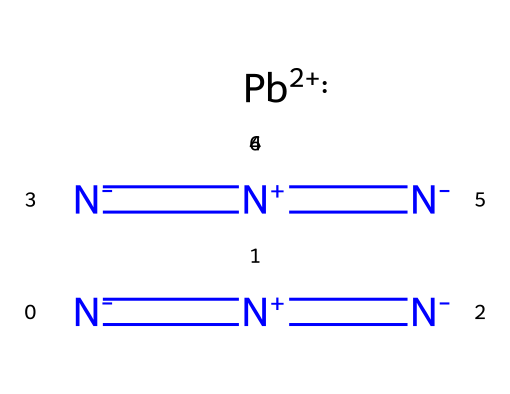What is the central atom in lead azide? The central atom in the structure is lead, which is represented in the SMILES notation as [Pb+2]. This indicates that lead is the primary element around which the azide groups are coordinated.
Answer: lead How many nitrogen atoms are present in lead azide? In the SMILES notation provided, there are two azide groups represented by [N-]=[N+]=[N-], and each group contains three nitrogen atoms. Therefore, the total number of nitrogen atoms is 6 (3 from each azide group).
Answer: 6 What is the charge of the lead atom in this compound? The lead atom in lead azide is shown to have a +2 charge in the SMILES notation as [Pb+2], indicating it is in the oxidation state of +2.
Answer: +2 Which functional group characterizes the azide component of this compound? The components [N-]=[N+]=[N-] in the SMILES structure define an azide functional group, where the arrangement of nitrogen atoms with alternating charges indicates its unique properties.
Answer: azide How many bonds are formed between the nitrogen atoms in the azide groups? Each azide group contains two double bonds between the nitrogen atoms as indicated by the "=" signs in the SMILES representation ([N-]=[N+]=[N-]). Each group has two such bonds leading to a total of 4 bonds across both groups.
Answer: 4 What is the overall charge of lead azide when combining the charges of the azides and lead? Each azide group contributes -1 charge, totaling -2 from the two azides, while the lead contributes +2, resulting in an overall neutral charge for the compound.
Answer: neutral 